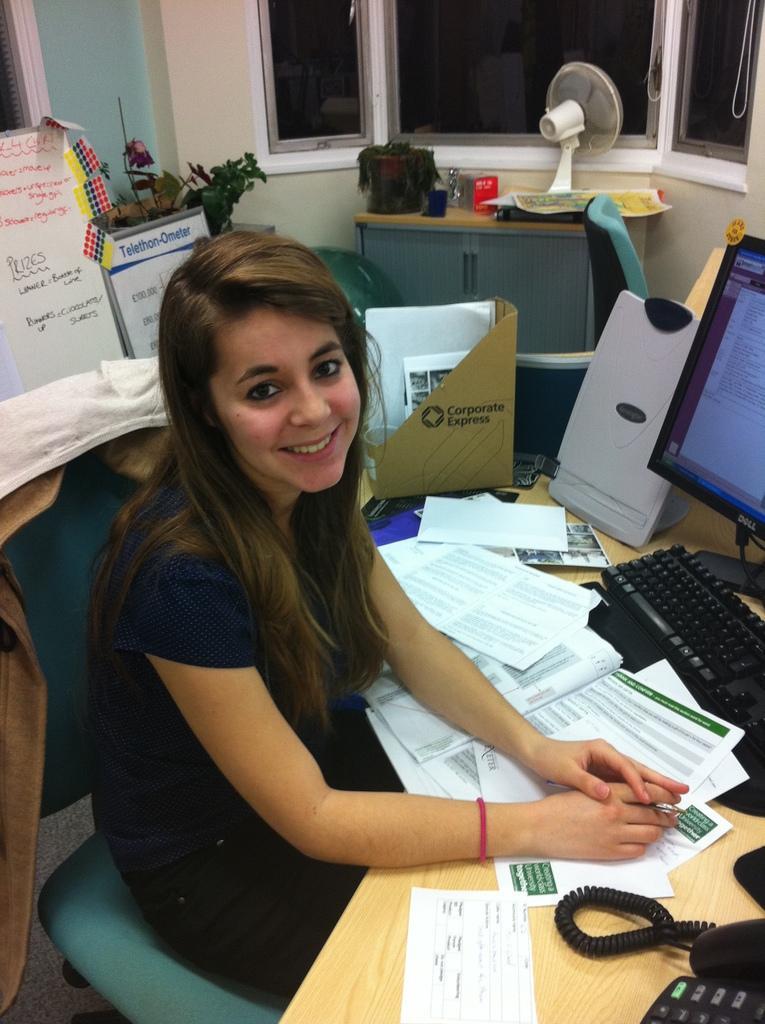In one or two sentences, can you explain what this image depicts? The image is inside the room. In the image there is a woman sitting on chair and she is also having smile on her face in front of a table, on table we can see land mobile,paper,keyboard,monitor,speaker. In background there is a table,fan, windows which are closed and a hoardings. 